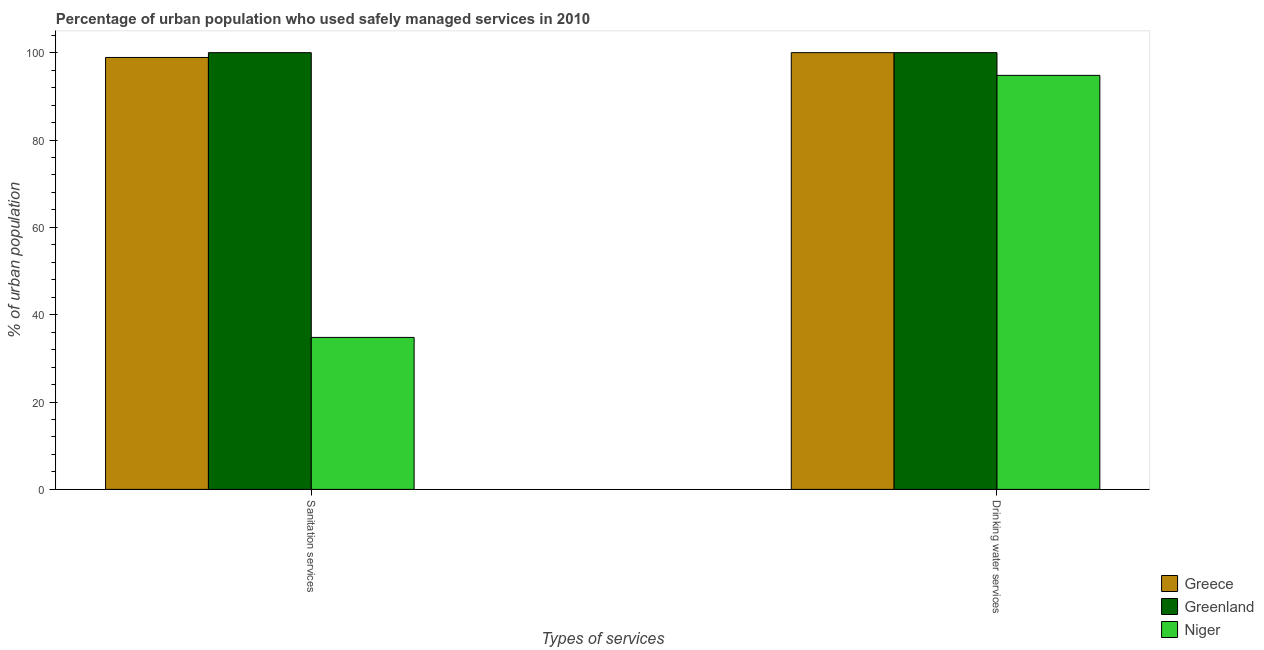How many groups of bars are there?
Your answer should be very brief. 2. Are the number of bars per tick equal to the number of legend labels?
Provide a succinct answer. Yes. What is the label of the 1st group of bars from the left?
Offer a terse response. Sanitation services. What is the percentage of urban population who used drinking water services in Niger?
Make the answer very short. 94.8. Across all countries, what is the minimum percentage of urban population who used sanitation services?
Your answer should be compact. 34.8. In which country was the percentage of urban population who used sanitation services maximum?
Make the answer very short. Greenland. In which country was the percentage of urban population who used drinking water services minimum?
Make the answer very short. Niger. What is the total percentage of urban population who used sanitation services in the graph?
Provide a short and direct response. 233.7. What is the difference between the percentage of urban population who used sanitation services in Niger and that in Greece?
Your answer should be very brief. -64.1. What is the difference between the percentage of urban population who used sanitation services in Greece and the percentage of urban population who used drinking water services in Greenland?
Give a very brief answer. -1.1. What is the average percentage of urban population who used sanitation services per country?
Your response must be concise. 77.9. What is the difference between the percentage of urban population who used sanitation services and percentage of urban population who used drinking water services in Niger?
Your answer should be compact. -60. In how many countries, is the percentage of urban population who used drinking water services greater than 56 %?
Keep it short and to the point. 3. What is the ratio of the percentage of urban population who used sanitation services in Niger to that in Greenland?
Provide a succinct answer. 0.35. What does the 2nd bar from the left in Drinking water services represents?
Your answer should be very brief. Greenland. What does the 3rd bar from the right in Sanitation services represents?
Offer a terse response. Greece. Are all the bars in the graph horizontal?
Provide a succinct answer. No. Are the values on the major ticks of Y-axis written in scientific E-notation?
Your answer should be very brief. No. How many legend labels are there?
Keep it short and to the point. 3. How are the legend labels stacked?
Offer a very short reply. Vertical. What is the title of the graph?
Offer a terse response. Percentage of urban population who used safely managed services in 2010. Does "France" appear as one of the legend labels in the graph?
Make the answer very short. No. What is the label or title of the X-axis?
Provide a short and direct response. Types of services. What is the label or title of the Y-axis?
Provide a short and direct response. % of urban population. What is the % of urban population of Greece in Sanitation services?
Ensure brevity in your answer.  98.9. What is the % of urban population of Niger in Sanitation services?
Give a very brief answer. 34.8. What is the % of urban population of Greece in Drinking water services?
Ensure brevity in your answer.  100. What is the % of urban population in Greenland in Drinking water services?
Give a very brief answer. 100. What is the % of urban population of Niger in Drinking water services?
Give a very brief answer. 94.8. Across all Types of services, what is the maximum % of urban population of Greece?
Make the answer very short. 100. Across all Types of services, what is the maximum % of urban population in Niger?
Make the answer very short. 94.8. Across all Types of services, what is the minimum % of urban population of Greece?
Give a very brief answer. 98.9. Across all Types of services, what is the minimum % of urban population in Greenland?
Your response must be concise. 100. Across all Types of services, what is the minimum % of urban population in Niger?
Ensure brevity in your answer.  34.8. What is the total % of urban population of Greece in the graph?
Ensure brevity in your answer.  198.9. What is the total % of urban population of Niger in the graph?
Your response must be concise. 129.6. What is the difference between the % of urban population of Niger in Sanitation services and that in Drinking water services?
Give a very brief answer. -60. What is the difference between the % of urban population of Greece in Sanitation services and the % of urban population of Greenland in Drinking water services?
Make the answer very short. -1.1. What is the difference between the % of urban population in Greece in Sanitation services and the % of urban population in Niger in Drinking water services?
Your response must be concise. 4.1. What is the difference between the % of urban population of Greenland in Sanitation services and the % of urban population of Niger in Drinking water services?
Ensure brevity in your answer.  5.2. What is the average % of urban population in Greece per Types of services?
Offer a very short reply. 99.45. What is the average % of urban population in Greenland per Types of services?
Give a very brief answer. 100. What is the average % of urban population of Niger per Types of services?
Ensure brevity in your answer.  64.8. What is the difference between the % of urban population of Greece and % of urban population of Greenland in Sanitation services?
Provide a succinct answer. -1.1. What is the difference between the % of urban population of Greece and % of urban population of Niger in Sanitation services?
Provide a succinct answer. 64.1. What is the difference between the % of urban population of Greenland and % of urban population of Niger in Sanitation services?
Make the answer very short. 65.2. What is the difference between the % of urban population in Greece and % of urban population in Niger in Drinking water services?
Your response must be concise. 5.2. What is the difference between the % of urban population in Greenland and % of urban population in Niger in Drinking water services?
Make the answer very short. 5.2. What is the ratio of the % of urban population of Niger in Sanitation services to that in Drinking water services?
Your answer should be compact. 0.37. What is the difference between the highest and the second highest % of urban population of Greenland?
Your answer should be compact. 0. What is the difference between the highest and the second highest % of urban population in Niger?
Ensure brevity in your answer.  60. What is the difference between the highest and the lowest % of urban population of Greece?
Offer a very short reply. 1.1. What is the difference between the highest and the lowest % of urban population of Greenland?
Offer a very short reply. 0. What is the difference between the highest and the lowest % of urban population of Niger?
Make the answer very short. 60. 